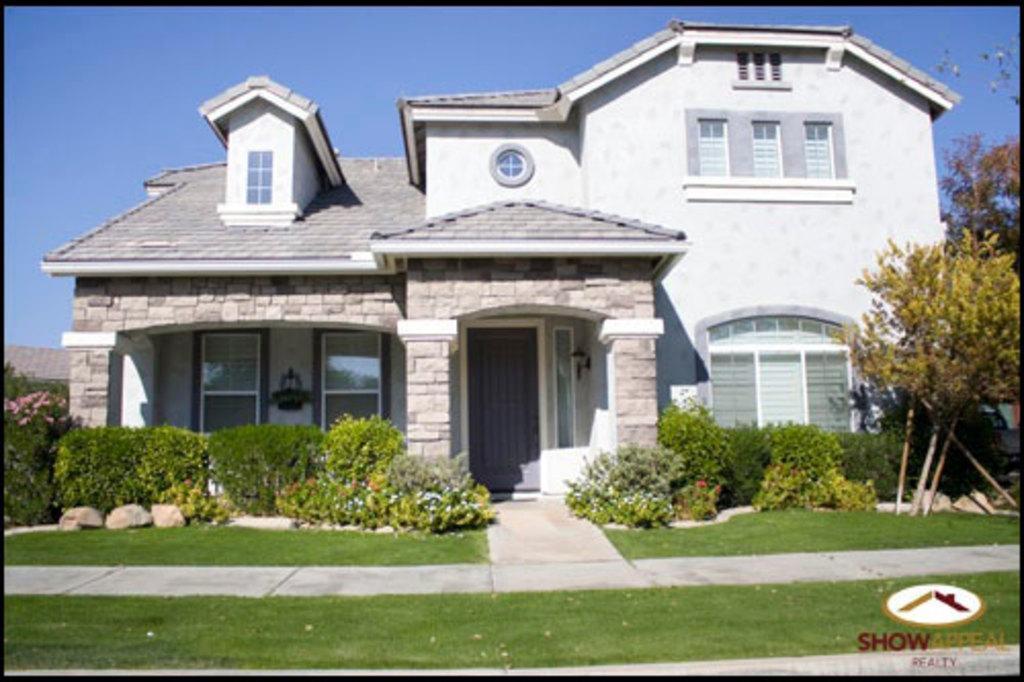Describe this image in one or two sentences. In this picture there is a house. In front of the house we can see plants, trees, grass and stones. Here we can see doors, windows and light. On the top there is a sky. On the bottom right corner there is a watermark. 